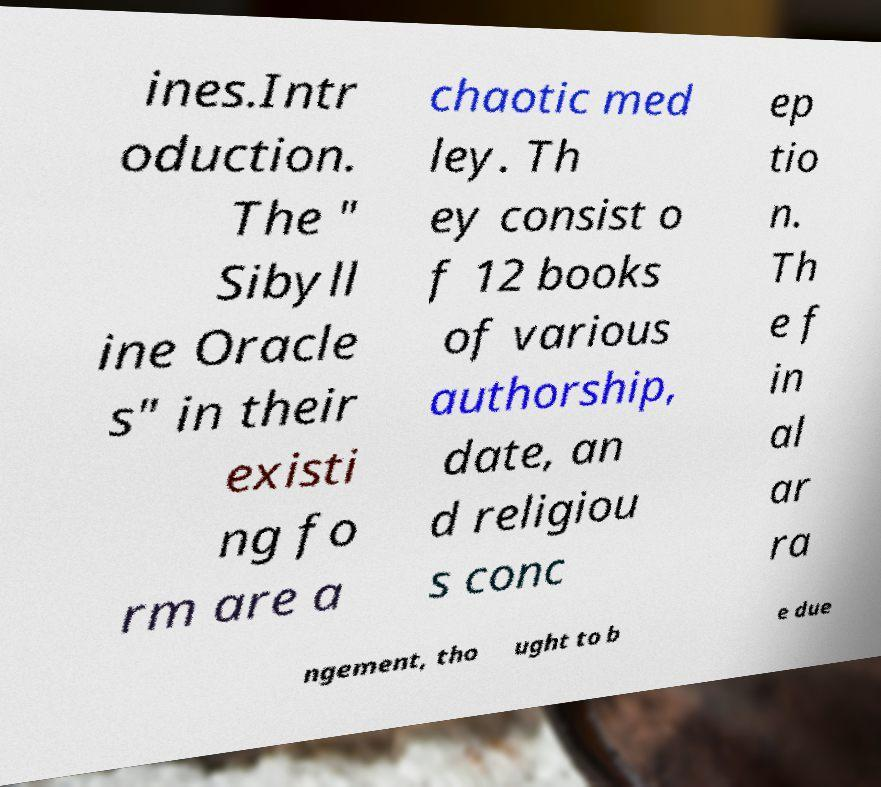Please identify and transcribe the text found in this image. ines.Intr oduction. The " Sibyll ine Oracle s" in their existi ng fo rm are a chaotic med ley. Th ey consist o f 12 books of various authorship, date, an d religiou s conc ep tio n. Th e f in al ar ra ngement, tho ught to b e due 